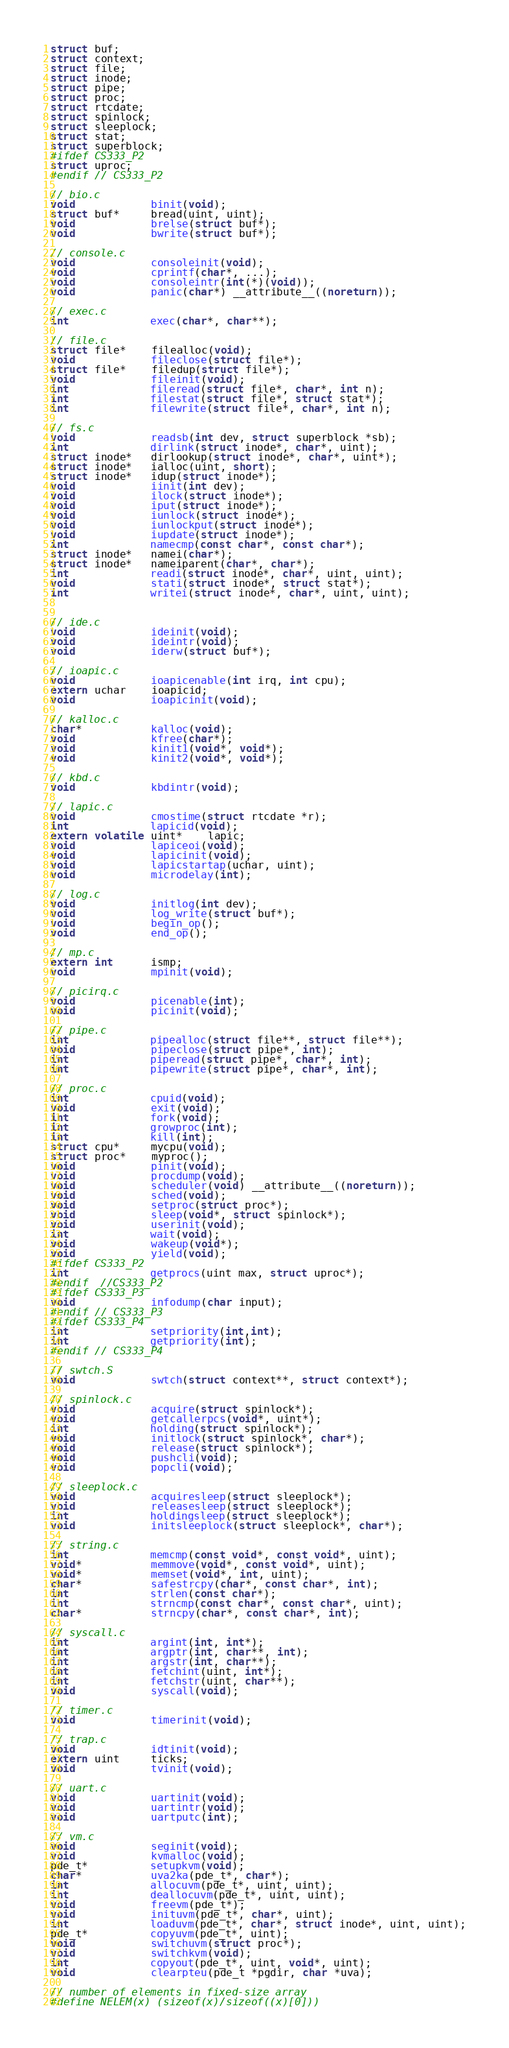<code> <loc_0><loc_0><loc_500><loc_500><_C_>struct buf;
struct context;
struct file;
struct inode;
struct pipe;
struct proc;
struct rtcdate;
struct spinlock;
struct sleeplock;
struct stat;
struct superblock;
#ifdef CS333_P2
struct uproc;
#endif // CS333_P2

// bio.c
void            binit(void);
struct buf*     bread(uint, uint);
void            brelse(struct buf*);
void            bwrite(struct buf*);

// console.c
void            consoleinit(void);
void            cprintf(char*, ...);
void            consoleintr(int(*)(void));
void            panic(char*) __attribute__((noreturn));

// exec.c
int             exec(char*, char**);

// file.c
struct file*    filealloc(void);
void            fileclose(struct file*);
struct file*    filedup(struct file*);
void            fileinit(void);
int             fileread(struct file*, char*, int n);
int             filestat(struct file*, struct stat*);
int             filewrite(struct file*, char*, int n);

// fs.c
void            readsb(int dev, struct superblock *sb);
int             dirlink(struct inode*, char*, uint);
struct inode*   dirlookup(struct inode*, char*, uint*);
struct inode*   ialloc(uint, short);
struct inode*   idup(struct inode*);
void            iinit(int dev);
void            ilock(struct inode*);
void            iput(struct inode*);
void            iunlock(struct inode*);
void            iunlockput(struct inode*);
void            iupdate(struct inode*);
int             namecmp(const char*, const char*);
struct inode*   namei(char*);
struct inode*   nameiparent(char*, char*);
int             readi(struct inode*, char*, uint, uint);
void            stati(struct inode*, struct stat*);
int             writei(struct inode*, char*, uint, uint);


// ide.c
void            ideinit(void);
void            ideintr(void);
void            iderw(struct buf*);

// ioapic.c
void            ioapicenable(int irq, int cpu);
extern uchar    ioapicid;
void            ioapicinit(void);

// kalloc.c
char*           kalloc(void);
void            kfree(char*);
void            kinit1(void*, void*);
void            kinit2(void*, void*);

// kbd.c
void            kbdintr(void);

// lapic.c
void            cmostime(struct rtcdate *r);
int             lapicid(void);
extern volatile uint*    lapic;
void            lapiceoi(void);
void            lapicinit(void);
void            lapicstartap(uchar, uint);
void            microdelay(int);

// log.c
void            initlog(int dev);
void            log_write(struct buf*);
void            begin_op();
void            end_op();

// mp.c
extern int      ismp;
void            mpinit(void);

// picirq.c
void            picenable(int);
void            picinit(void);

// pipe.c
int             pipealloc(struct file**, struct file**);
void            pipeclose(struct pipe*, int);
int             piperead(struct pipe*, char*, int);
int             pipewrite(struct pipe*, char*, int);

// proc.c
int             cpuid(void);
void            exit(void);
int             fork(void);
int             growproc(int);
int             kill(int);
struct cpu*     mycpu(void);
struct proc*    myproc();
void            pinit(void);
void            procdump(void);
void            scheduler(void) __attribute__((noreturn));
void            sched(void);
void            setproc(struct proc*);
void            sleep(void*, struct spinlock*);
void            userinit(void);
int             wait(void);
void            wakeup(void*);
void            yield(void);
#ifdef CS333_P2
int             getprocs(uint max, struct uproc*);
#endif  //CS333_P2
#ifdef CS333_P3
void            infodump(char input);
#endif // CS333_P3
#ifdef CS333_P4
int             setpriority(int,int);
int             getpriority(int);
#endif // CS333_P4

// swtch.S
void            swtch(struct context**, struct context*);

// spinlock.c
void            acquire(struct spinlock*);
void            getcallerpcs(void*, uint*);
int             holding(struct spinlock*);
void            initlock(struct spinlock*, char*);
void            release(struct spinlock*);
void            pushcli(void);
void            popcli(void);

// sleeplock.c
void            acquiresleep(struct sleeplock*);
void            releasesleep(struct sleeplock*);
int             holdingsleep(struct sleeplock*);
void            initsleeplock(struct sleeplock*, char*);

// string.c
int             memcmp(const void*, const void*, uint);
void*           memmove(void*, const void*, uint);
void*           memset(void*, int, uint);
char*           safestrcpy(char*, const char*, int);
int             strlen(const char*);
int             strncmp(const char*, const char*, uint);
char*           strncpy(char*, const char*, int);

// syscall.c
int             argint(int, int*);
int             argptr(int, char**, int);
int             argstr(int, char**);
int             fetchint(uint, int*);
int             fetchstr(uint, char**);
void            syscall(void);

// timer.c
void            timerinit(void);

// trap.c
void            idtinit(void);
extern uint     ticks;
void            tvinit(void);

// uart.c
void            uartinit(void);
void            uartintr(void);
void            uartputc(int);

// vm.c
void            seginit(void);
void            kvmalloc(void);
pde_t*          setupkvm(void);
char*           uva2ka(pde_t*, char*);
int             allocuvm(pde_t*, uint, uint);
int             deallocuvm(pde_t*, uint, uint);
void            freevm(pde_t*);
void            inituvm(pde_t*, char*, uint);
int             loaduvm(pde_t*, char*, struct inode*, uint, uint);
pde_t*          copyuvm(pde_t*, uint);
void            switchuvm(struct proc*);
void            switchkvm(void);
int             copyout(pde_t*, uint, void*, uint);
void            clearpteu(pde_t *pgdir, char *uva);

// number of elements in fixed-size array
#define NELEM(x) (sizeof(x)/sizeof((x)[0]))
</code> 